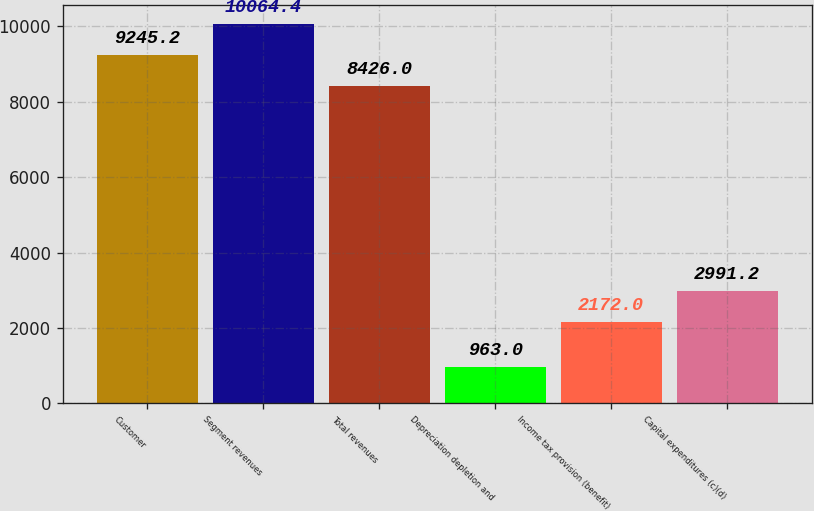Convert chart. <chart><loc_0><loc_0><loc_500><loc_500><bar_chart><fcel>Customer<fcel>Segment revenues<fcel>Total revenues<fcel>Depreciation depletion and<fcel>Income tax provision (benefit)<fcel>Capital expenditures (c)(d)<nl><fcel>9245.2<fcel>10064.4<fcel>8426<fcel>963<fcel>2172<fcel>2991.2<nl></chart> 